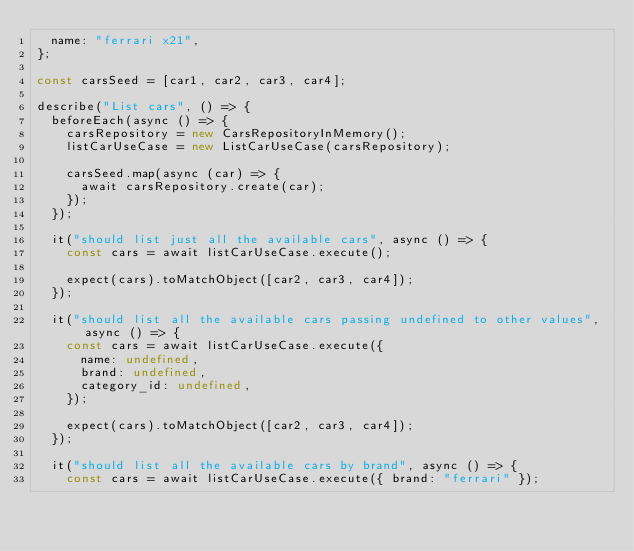<code> <loc_0><loc_0><loc_500><loc_500><_TypeScript_>  name: "ferrari x21",
};

const carsSeed = [car1, car2, car3, car4];

describe("List cars", () => {
  beforeEach(async () => {
    carsRepository = new CarsRepositoryInMemory();
    listCarUseCase = new ListCarUseCase(carsRepository);

    carsSeed.map(async (car) => {
      await carsRepository.create(car);
    });
  });

  it("should list just all the available cars", async () => {
    const cars = await listCarUseCase.execute();

    expect(cars).toMatchObject([car2, car3, car4]);
  });

  it("should list all the available cars passing undefined to other values", async () => {
    const cars = await listCarUseCase.execute({
      name: undefined,
      brand: undefined,
      category_id: undefined,
    });

    expect(cars).toMatchObject([car2, car3, car4]);
  });

  it("should list all the available cars by brand", async () => {
    const cars = await listCarUseCase.execute({ brand: "ferrari" });
</code> 